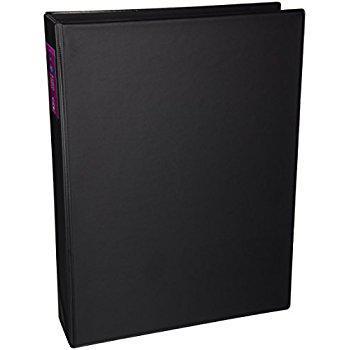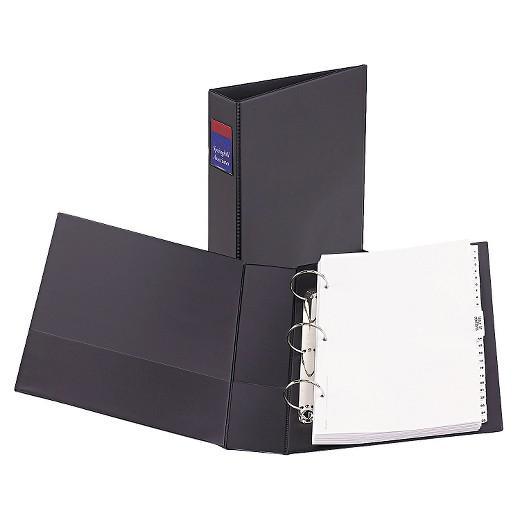The first image is the image on the left, the second image is the image on the right. Considering the images on both sides, is "One image shows a single upright black binder, and the other image shows a paper-filled open binder lying by at least one upright closed binder." valid? Answer yes or no. Yes. The first image is the image on the left, the second image is the image on the right. Considering the images on both sides, is "The binder in the image on the right is open to show white pages." valid? Answer yes or no. Yes. 